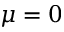<formula> <loc_0><loc_0><loc_500><loc_500>\mu = 0</formula> 